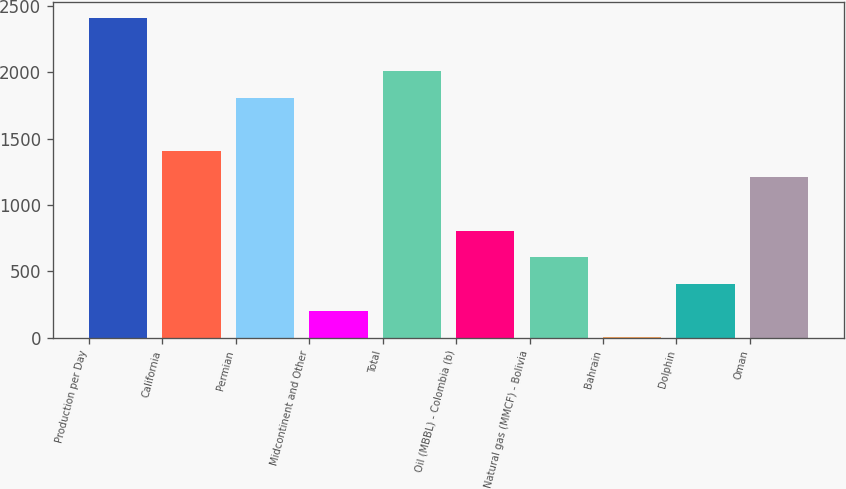Convert chart. <chart><loc_0><loc_0><loc_500><loc_500><bar_chart><fcel>Production per Day<fcel>California<fcel>Permian<fcel>Midcontinent and Other<fcel>Total<fcel>Oil (MBBL) - Colombia (b)<fcel>Natural gas (MMCF) - Bolivia<fcel>Bahrain<fcel>Dolphin<fcel>Oman<nl><fcel>2411.4<fcel>1407.9<fcel>1809.3<fcel>203.7<fcel>2010<fcel>805.8<fcel>605.1<fcel>3<fcel>404.4<fcel>1207.2<nl></chart> 